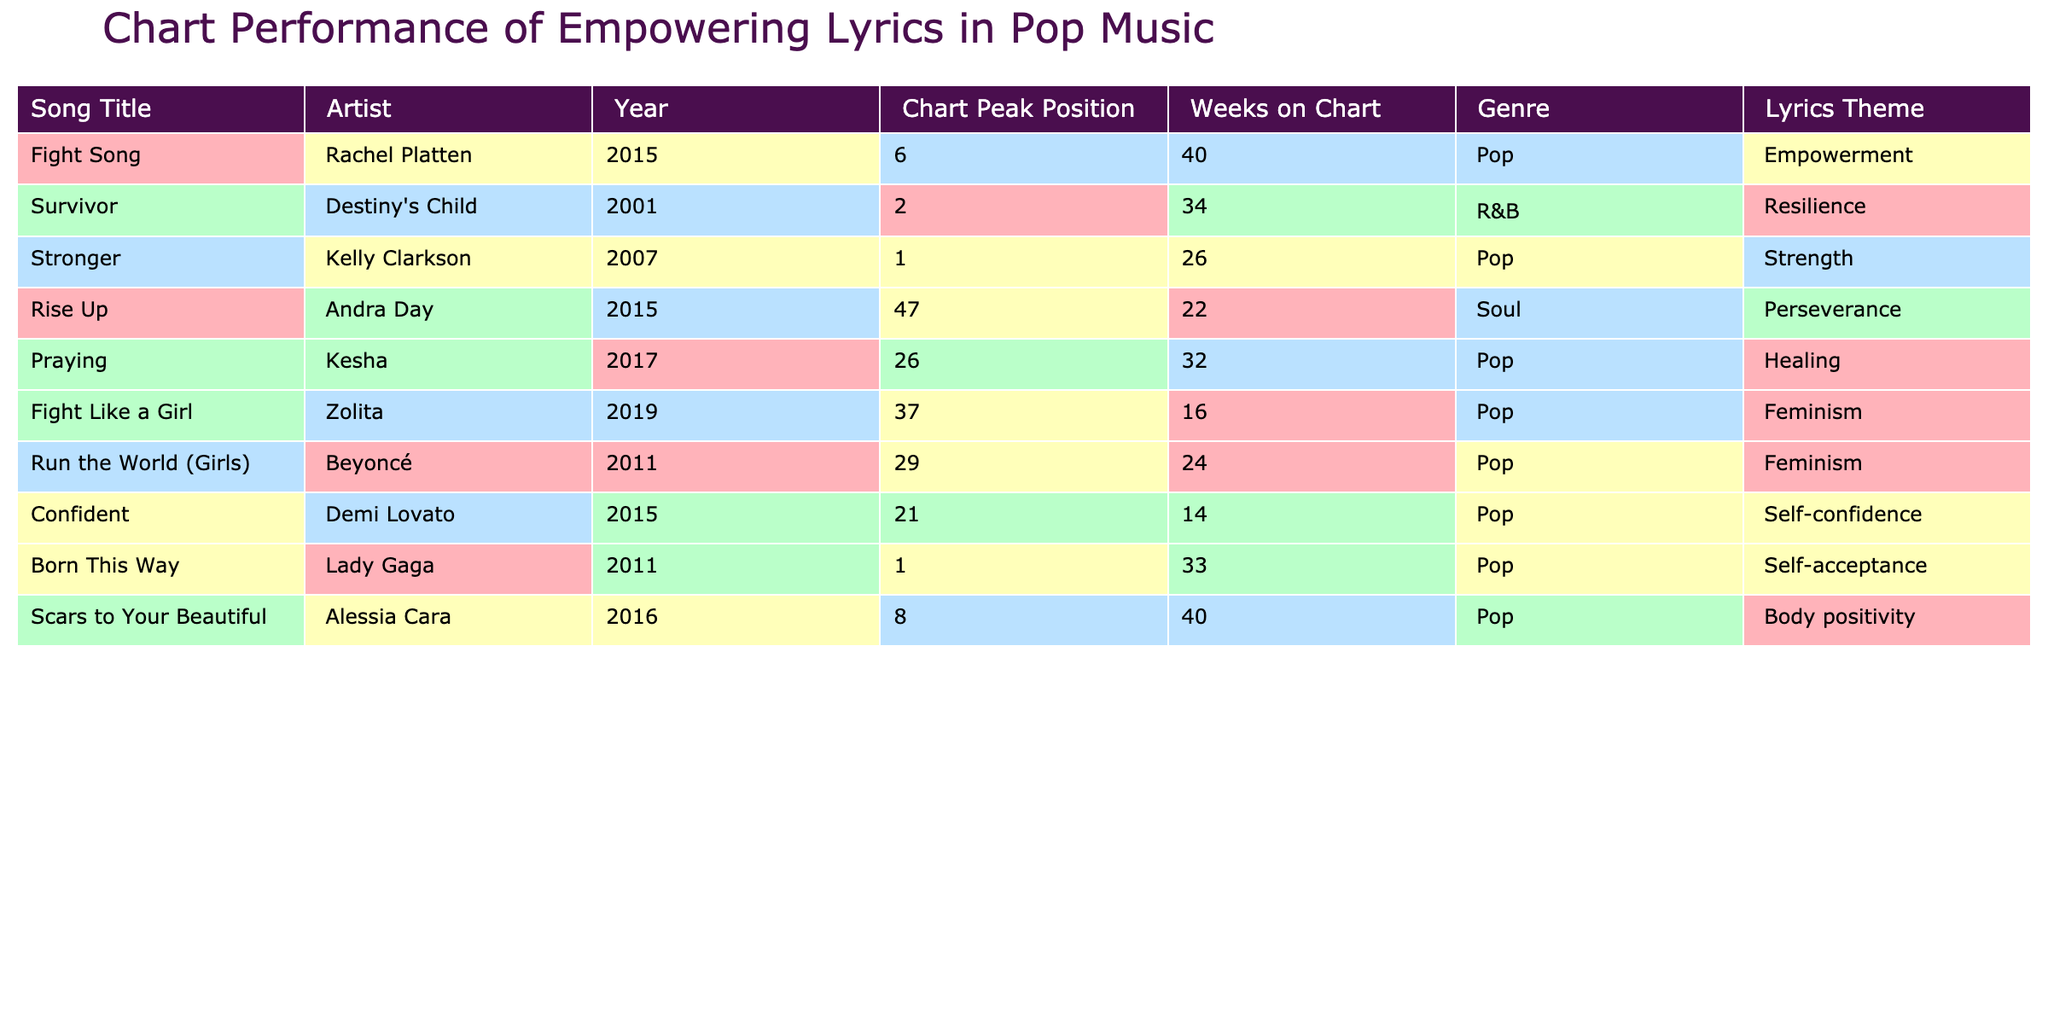What is the peak chart position of "Fight Song"? The table displays the information for "Fight Song", which shows its peak chart position as 6.
Answer: 6 Which song spent the most weeks on the chart? Looking at the "Weeks on Chart" column, "Fight Song" and "Scars to Your Beautiful" both spent 40 weeks, which is the highest in the table.
Answer: 40 weeks Did any songs chart at position 1? Yes, the table lists "Stronger" by Kelly Clarkson and "Born This Way" by Lady Gaga both reaching chart position 1.
Answer: Yes What is the average peak position of the songs listed? To find the average, we sum all peak positions: (6 + 2 + 1 + 47 + 26 + 37 + 29 + 21 + 1 + 8) = 208, and there are 10 songs, so the average is 208/10 = 20.8.
Answer: 20.8 Which song from the table falls into the genre of Soul? The table indicates that "Rise Up" by Andra Day is the only song categorized as Soul.
Answer: Rise Up How many songs in the table have a lyrics theme of empowerment? "Fight Song" by Rachel Platten and "Stronger" by Kelly Clarkson are explicitly related to empowerment, making a total of 2 songs with that theme.
Answer: 2 songs Is there a song with the lyrics theme of self-acceptance? Yes, the table shows that "Born This Way" by Lady Gaga falls under the theme of self-acceptance.
Answer: Yes What is the difference in peak positions between "Fight Song" and "Scars to Your Beautiful"? "Fight Song" peaked at 6 and "Scars to Your Beautiful" peaked at 8, so the difference is 8 - 6 = 2.
Answer: 2 Which artist has the highest number of weeks on the chart for their song? Rachel Platten's "Fight Song" and Alessia Cara's "Scars to Your Beautiful" both have the highest weeks at 40, which signifies the highest tenure on the chart.
Answer: Rachel Platten and Alessia Cara If we consider only songs from the last five years, which song had the best peak position? The most recent songs are "Praying" (26), "Fight Like a Girl" (37), and "Confident" (21), with "Confident" having the best peak position of 21.
Answer: Confident 